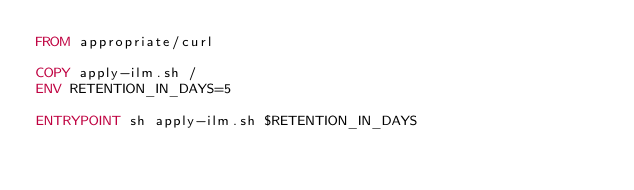<code> <loc_0><loc_0><loc_500><loc_500><_Dockerfile_>FROM appropriate/curl

COPY apply-ilm.sh /
ENV RETENTION_IN_DAYS=5

ENTRYPOINT sh apply-ilm.sh $RETENTION_IN_DAYS</code> 